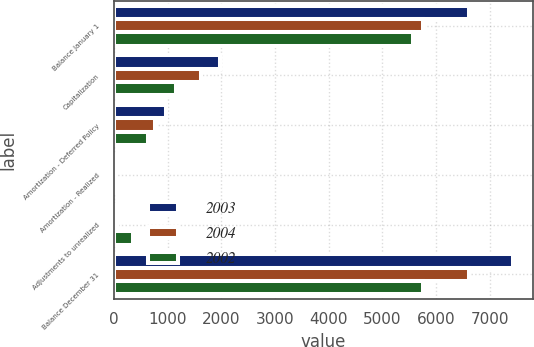Convert chart. <chart><loc_0><loc_0><loc_500><loc_500><stacked_bar_chart><ecel><fcel>Balance January 1<fcel>Capitalization<fcel>Amortization - Deferred Policy<fcel>Amortization - Realized<fcel>Adjustments to unrealized<fcel>Balance December 31<nl><fcel>2003<fcel>6624<fcel>1968<fcel>978<fcel>15<fcel>75<fcel>7438<nl><fcel>2004<fcel>5759<fcel>1626<fcel>769<fcel>14<fcel>59<fcel>6624<nl><fcel>2002<fcel>5573<fcel>1160<fcel>628<fcel>7<fcel>353<fcel>5759<nl></chart> 